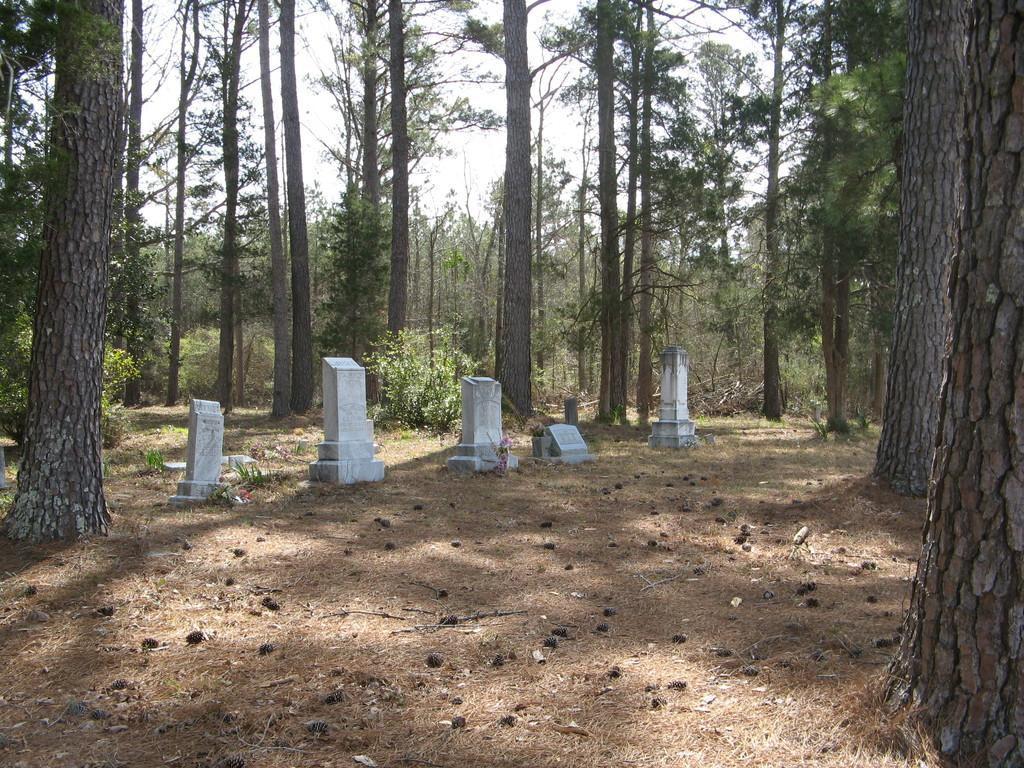What type of location is depicted in the image? There is a graveyard in the image. What type of vegetation can be seen in the image? There are trees and plants in the image. What is the ground covered with in the image? There is grass in the image. Where are the tombstones located in the image? The tombstones are on the left side of the image. What is visible in the background of the image? The sky is visible in the background of the image. Can you tell me how much milk the cow is producing in the image? There is no cow present in the image, so it is not possible to determine how much milk it might be producing. 